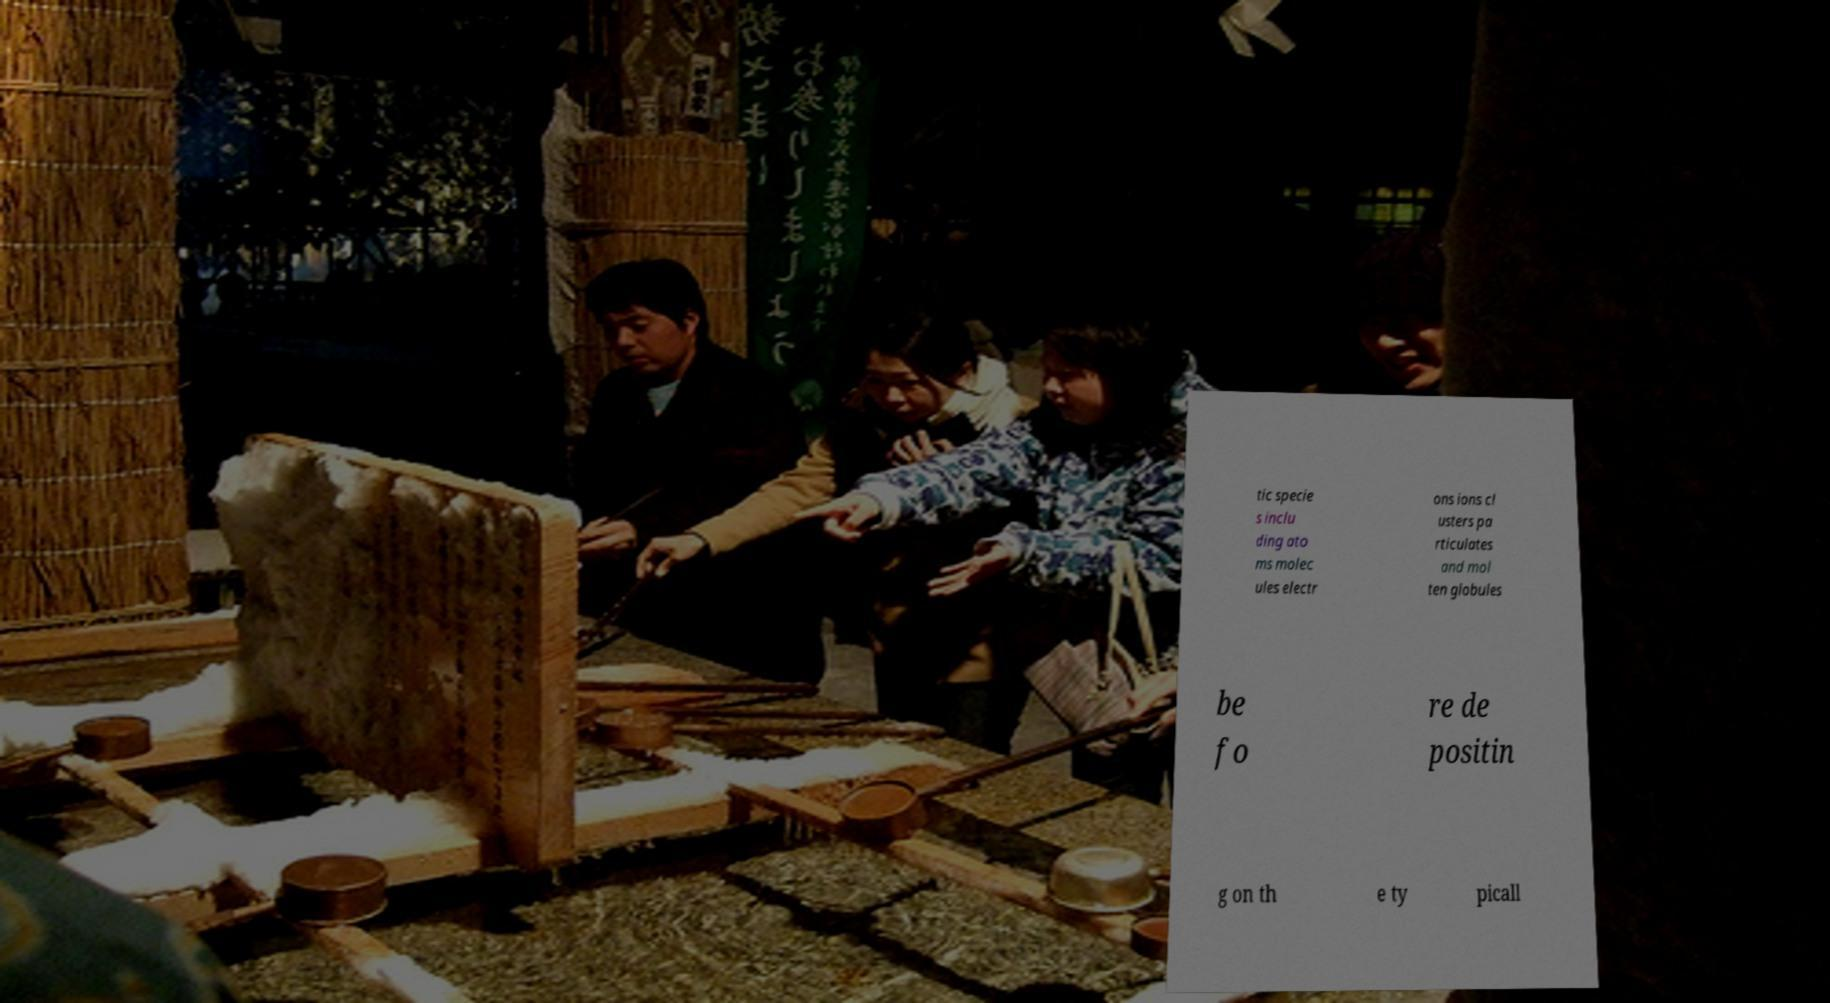I need the written content from this picture converted into text. Can you do that? tic specie s inclu ding ato ms molec ules electr ons ions cl usters pa rticulates and mol ten globules be fo re de positin g on th e ty picall 